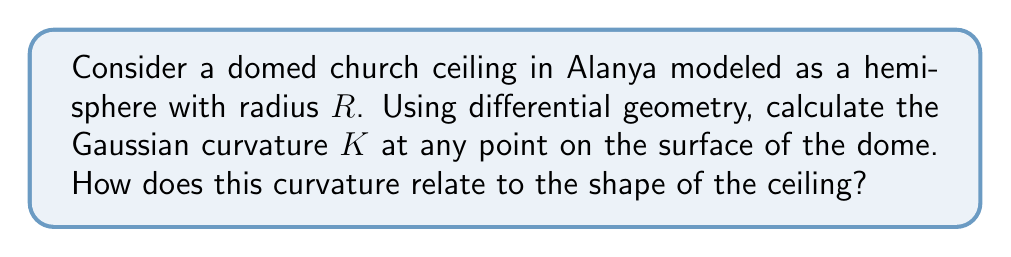Can you solve this math problem? Let's approach this step-by-step using differential geometry and tensor calculus:

1) First, we need to parameterize the hemisphere. We can use spherical coordinates:
   $$x = R\sin\theta\cos\phi$$
   $$y = R\sin\theta\sin\phi$$
   $$z = R\cos\theta$$
   where $0 \leq \theta \leq \frac{\pi}{2}$ and $0 \leq \phi < 2\pi$

2) The metric tensor $g_{ij}$ is given by:
   $$g_{11} = R^2$$
   $$g_{12} = g_{21} = 0$$
   $$g_{22} = R^2\sin^2\theta$$

3) The inverse metric tensor $g^{ij}$ is:
   $$g^{11} = \frac{1}{R^2}$$
   $$g^{12} = g^{21} = 0$$
   $$g^{22} = \frac{1}{R^2\sin^2\theta}$$

4) Next, we calculate the Christoffel symbols:
   $$\Gamma^1_{22} = -\sin\theta\cos\theta$$
   $$\Gamma^2_{12} = \Gamma^2_{21} = \cot\theta$$
   (All other symbols are zero)

5) Now we can calculate the Riemann curvature tensor:
   $$R^1_{212} = \sin^2\theta$$
   $$R^2_{121} = 1$$

6) The Ricci tensor is:
   $$R_{11} = 1$$
   $$R_{22} = \sin^2\theta$$

7) The scalar curvature is:
   $$R = \frac{2}{R^2}$$

8) Finally, the Gaussian curvature $K$ is half the scalar curvature:
   $$K = \frac{1}{R^2}$$

This constant positive curvature indicates that the dome has the same shape at every point, which is characteristic of a perfect hemisphere. The $\frac{1}{R^2}$ relationship shows that larger domes have less curvature, appearing flatter locally, while smaller domes have more pronounced curvature.
Answer: $K = \frac{1}{R^2}$ 